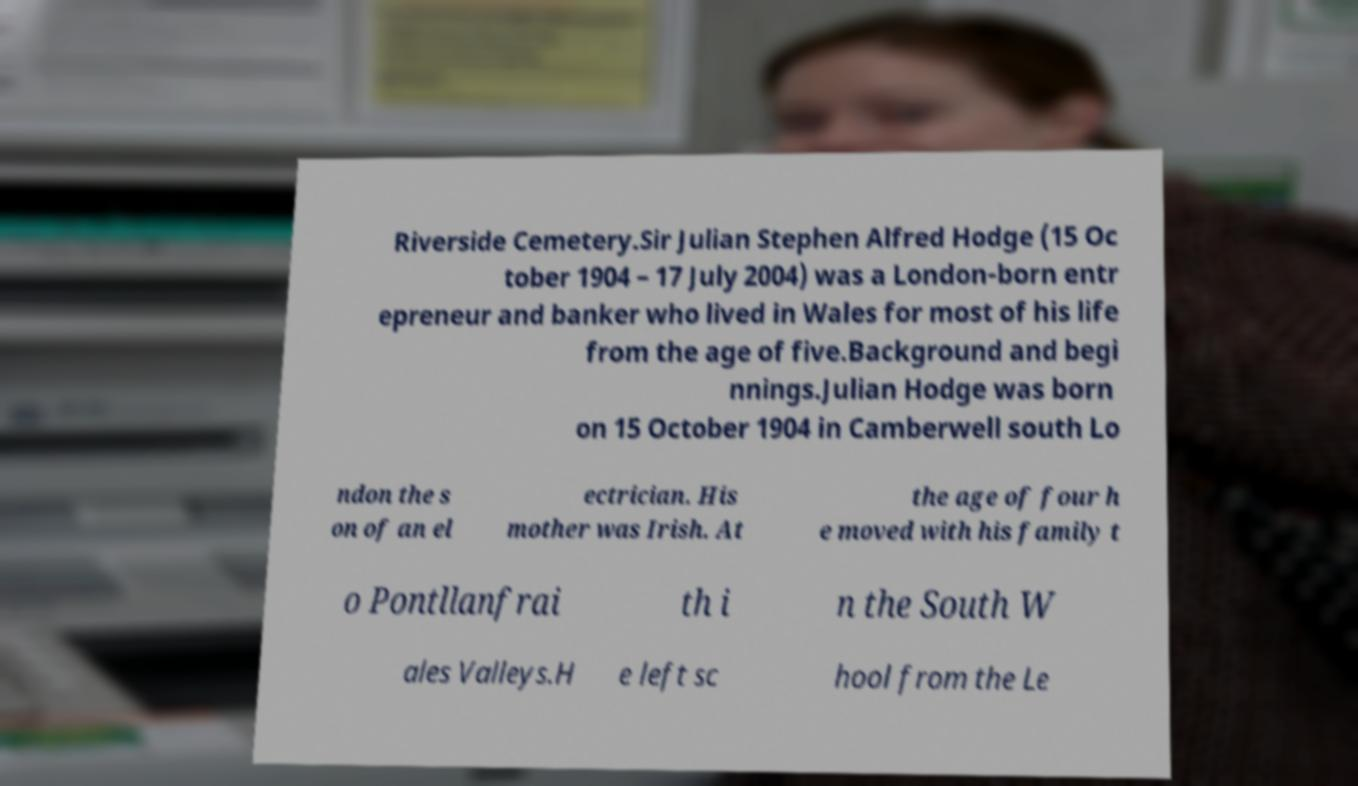Could you extract and type out the text from this image? Riverside Cemetery.Sir Julian Stephen Alfred Hodge (15 Oc tober 1904 – 17 July 2004) was a London-born entr epreneur and banker who lived in Wales for most of his life from the age of five.Background and begi nnings.Julian Hodge was born on 15 October 1904 in Camberwell south Lo ndon the s on of an el ectrician. His mother was Irish. At the age of four h e moved with his family t o Pontllanfrai th i n the South W ales Valleys.H e left sc hool from the Le 